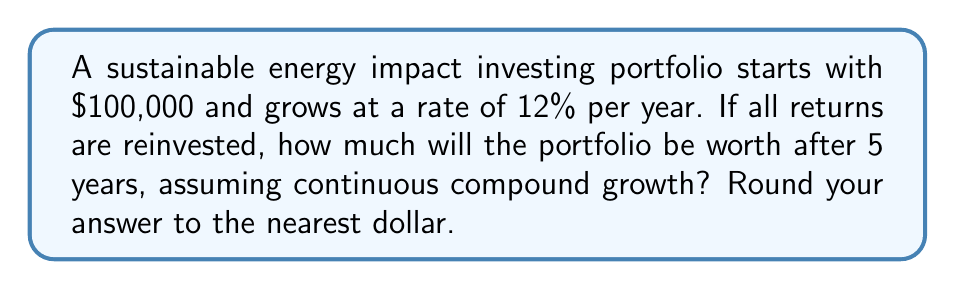Teach me how to tackle this problem. To solve this problem, we'll use the continuous compound growth formula:

$$A = P \cdot e^{rt}$$

Where:
$A$ = Final amount
$P$ = Principal (initial investment)
$r$ = Annual growth rate (as a decimal)
$t$ = Time in years
$e$ = Euler's number (approximately 2.71828)

Given:
$P = \$100,000$
$r = 12\% = 0.12$
$t = 5$ years

Let's substitute these values into the formula:

$$A = 100,000 \cdot e^{0.12 \cdot 5}$$

Now, let's calculate:

1) First, compute the exponent: $0.12 \cdot 5 = 0.6$

2) Calculate $e^{0.6}$:
   $e^{0.6} \approx 1.8221188$

3) Multiply by the initial investment:
   $100,000 \cdot 1.8221188 = 182,211.88$

4) Round to the nearest dollar:
   $182,212$

Therefore, after 5 years, the impact investing portfolio will be worth $182,212.
Answer: $182,212 